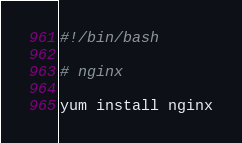Convert code to text. <code><loc_0><loc_0><loc_500><loc_500><_Bash_>#!/bin/bash

# nginx

yum install nginx
</code> 